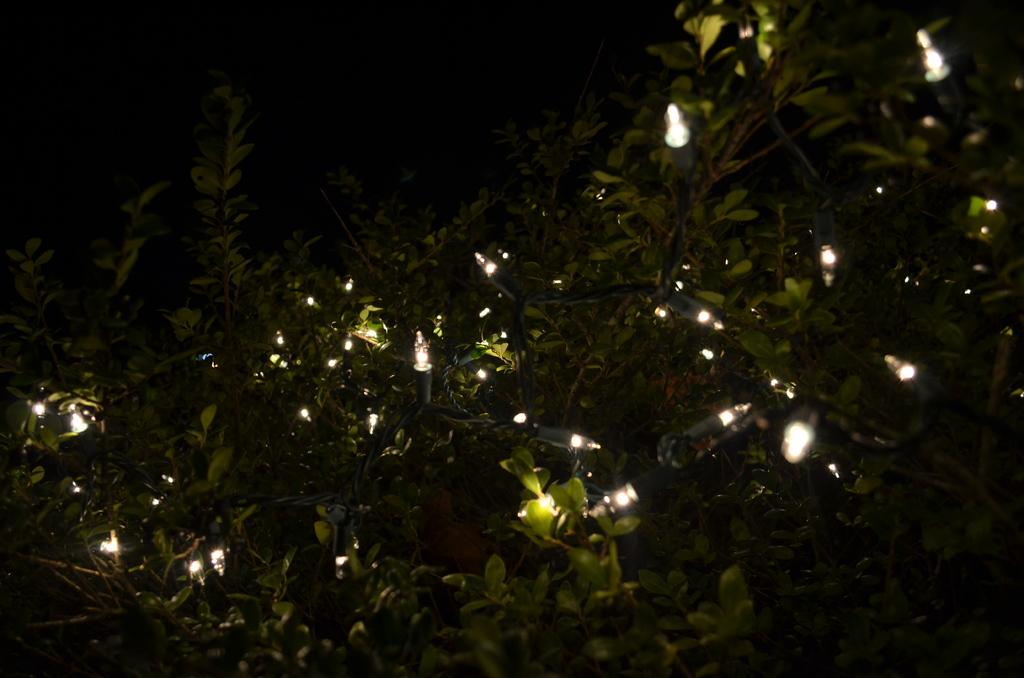What type of natural elements can be seen in the image? There are trees in the image. What type of artificial elements can be seen in the image? There are lights in the image. What is the color of the background in the image? The background of the image is black. What type of creature can be seen walking in the image? There is no creature present in the image, and therefore no such activity can be observed. What type of root can be seen growing in the image? There is no root visible in the image; it features trees and lights. 